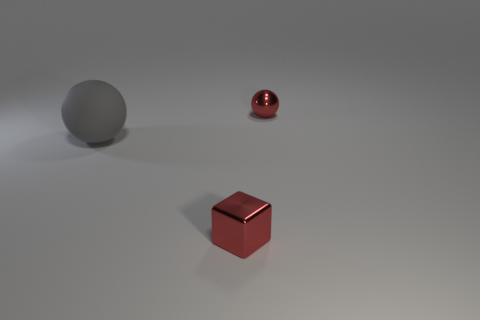What can you infer about the lighting and shadow effects in the scene? The image demonstrates a simple but effective use of lighting and shadows. There is a single key light source that creates distinct, soft shadows to the right of the objects, indicating that the light is coming from the left. The shadows are slightly blurred at the edges, suggesting the light source is not extremely close. These effects give the objects a sense of weight and position in the three-dimensional space. 